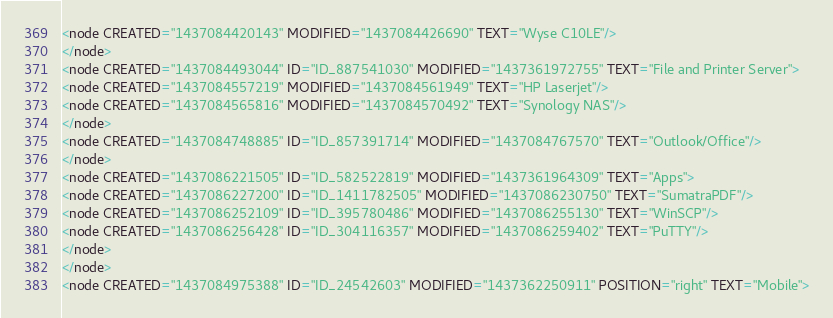<code> <loc_0><loc_0><loc_500><loc_500><_ObjectiveC_><node CREATED="1437084420143" MODIFIED="1437084426690" TEXT="Wyse C10LE"/>
</node>
<node CREATED="1437084493044" ID="ID_887541030" MODIFIED="1437361972755" TEXT="File and Printer Server">
<node CREATED="1437084557219" MODIFIED="1437084561949" TEXT="HP Laserjet"/>
<node CREATED="1437084565816" MODIFIED="1437084570492" TEXT="Synology NAS"/>
</node>
<node CREATED="1437084748885" ID="ID_857391714" MODIFIED="1437084767570" TEXT="Outlook/Office"/>
</node>
<node CREATED="1437086221505" ID="ID_582522819" MODIFIED="1437361964309" TEXT="Apps">
<node CREATED="1437086227200" ID="ID_1411782505" MODIFIED="1437086230750" TEXT="SumatraPDF"/>
<node CREATED="1437086252109" ID="ID_395780486" MODIFIED="1437086255130" TEXT="WinSCP"/>
<node CREATED="1437086256428" ID="ID_304116357" MODIFIED="1437086259402" TEXT="PuTTY"/>
</node>
</node>
<node CREATED="1437084975388" ID="ID_24542603" MODIFIED="1437362250911" POSITION="right" TEXT="Mobile"></code> 